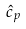<formula> <loc_0><loc_0><loc_500><loc_500>\hat { c } _ { p }</formula> 